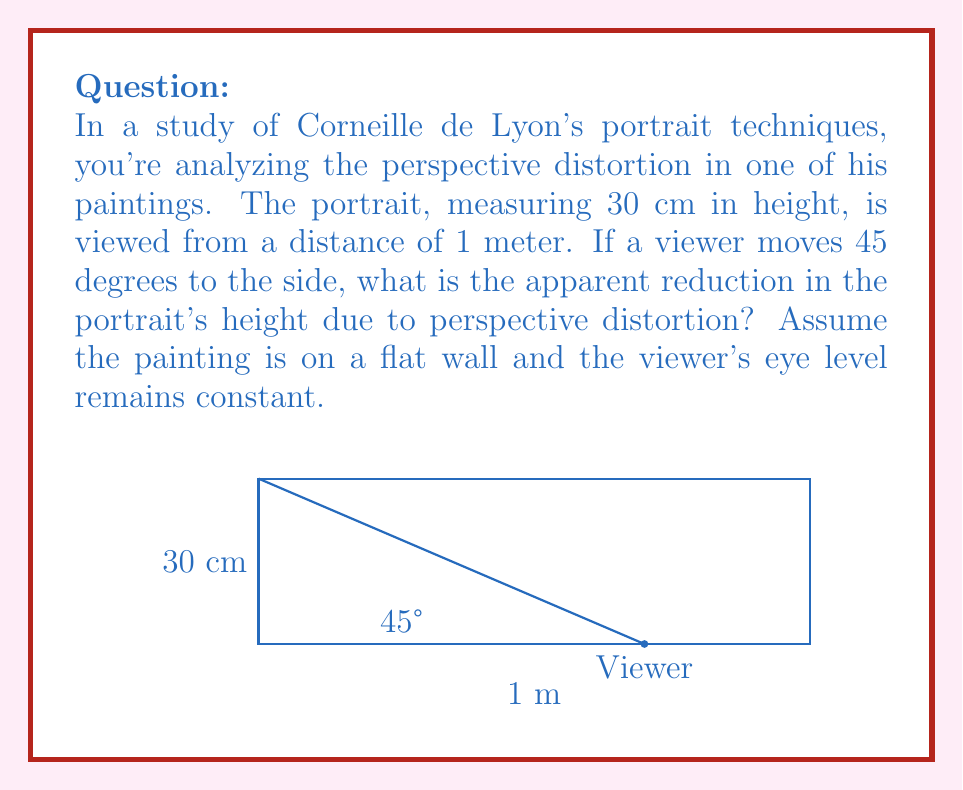Can you answer this question? To solve this problem, we'll follow these steps:

1) First, we need to understand that the apparent height of the portrait will be its projection onto a plane perpendicular to the viewer's line of sight.

2) The angle between the wall and the viewer's line of sight is 45°. Therefore, the projection will be:

   $h_{apparent} = h_{actual} \cdot \cos(45°)$

3) We know that $\cos(45°) = \frac{\sqrt{2}}{2}$

4) Substituting the values:

   $h_{apparent} = 30 \cdot \frac{\sqrt{2}}{2} \approx 21.21$ cm

5) To calculate the reduction:

   $\text{Reduction} = h_{actual} - h_{apparent}$
   $\text{Reduction} = 30 - 21.21 = 8.79$ cm

6) To express this as a percentage:

   $\text{Percentage Reduction} = \frac{\text{Reduction}}{h_{actual}} \cdot 100\%$
   $\text{Percentage Reduction} = \frac{8.79}{30} \cdot 100\% \approx 29.3\%$

Thus, the apparent height of the portrait is reduced by approximately 8.79 cm or 29.3% due to perspective distortion.
Answer: 8.79 cm (29.3%) 